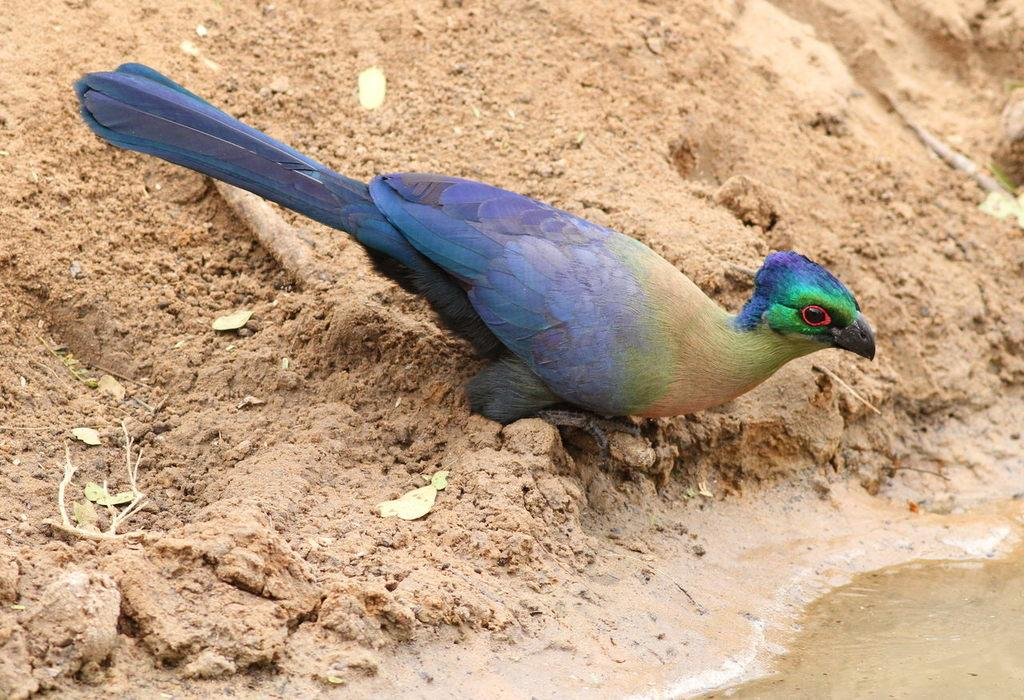What type of animal is in the image? There is a bird in the image. What colors can be seen on the bird? The bird has blue, green, cream, and red colors. Where is the bird located in the image? The bird is on the mud. What else can be seen in the image besides the bird? There is water visible in the image. What is the reaction of the bear in the office when it sees the bird in the image? There is no bear or office present in the image; it only features a bird on the mud with water visible. 